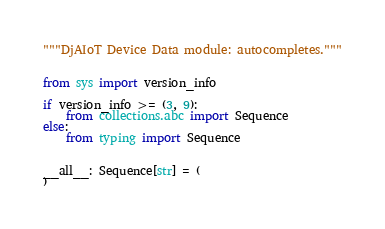<code> <loc_0><loc_0><loc_500><loc_500><_Python_>"""DjAIoT Device Data module: autocompletes."""


from sys import version_info

if version_info >= (3, 9):
    from collections.abc import Sequence
else:
    from typing import Sequence


__all__: Sequence[str] = (
)
</code> 